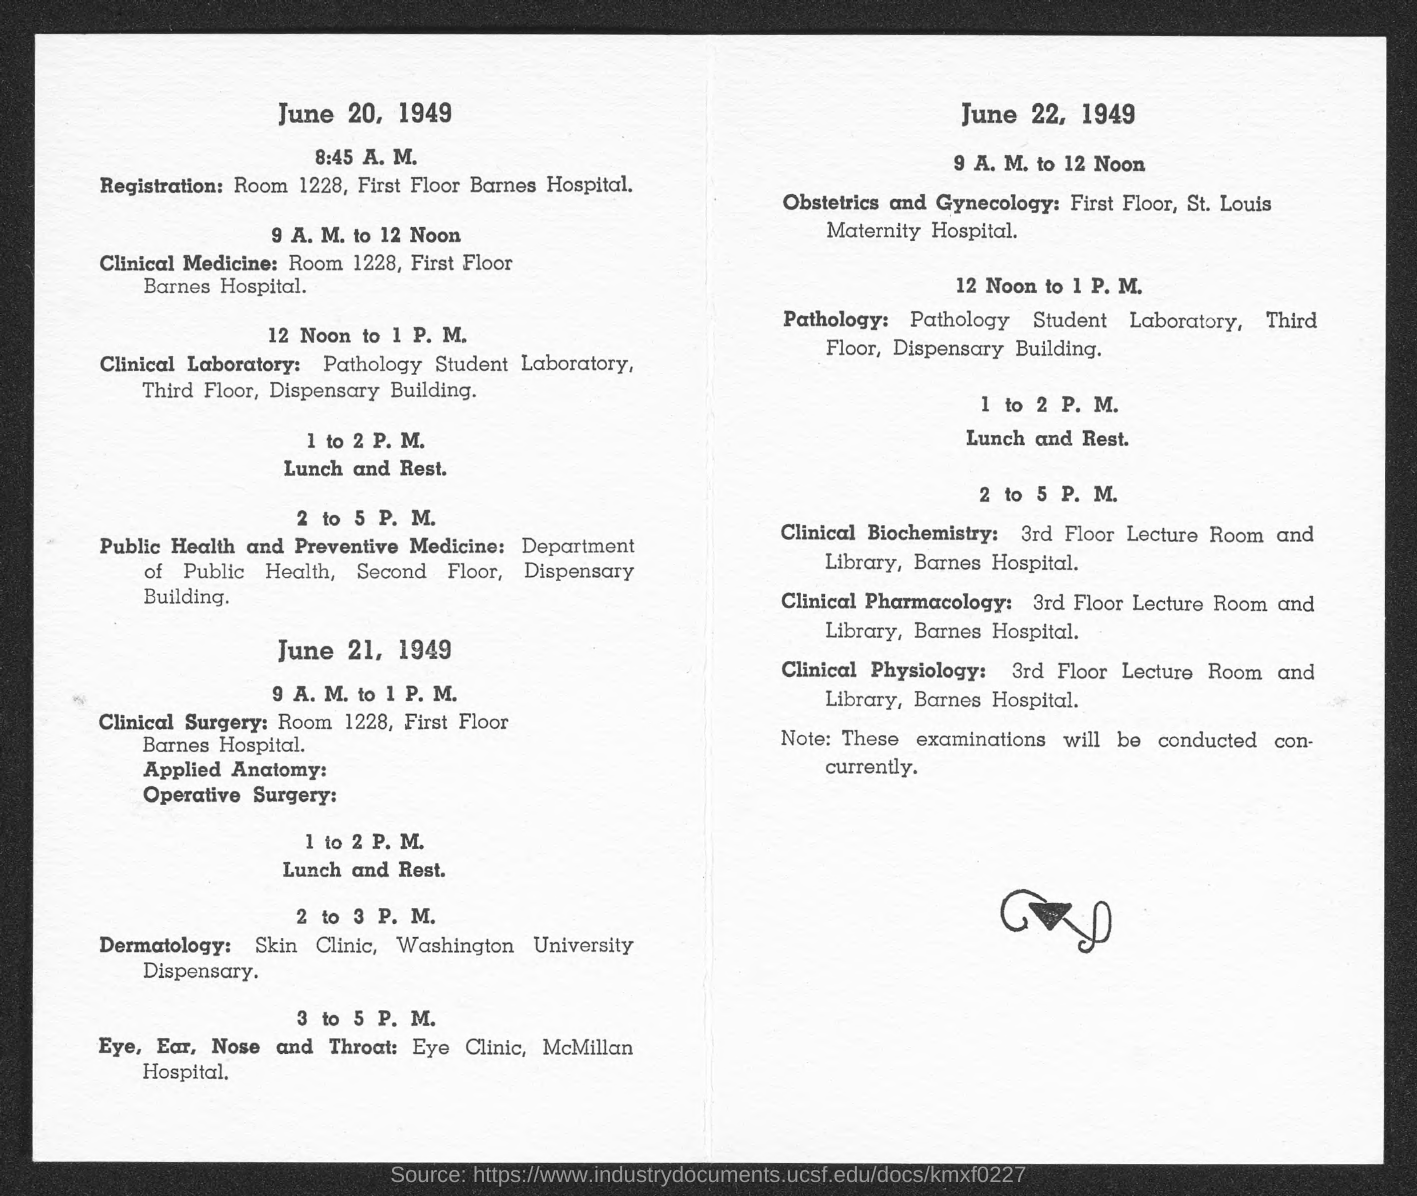Specify some key components in this picture. On June 20, the room number for registration is 1228. 